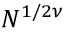<formula> <loc_0><loc_0><loc_500><loc_500>N ^ { 1 / 2 \nu }</formula> 